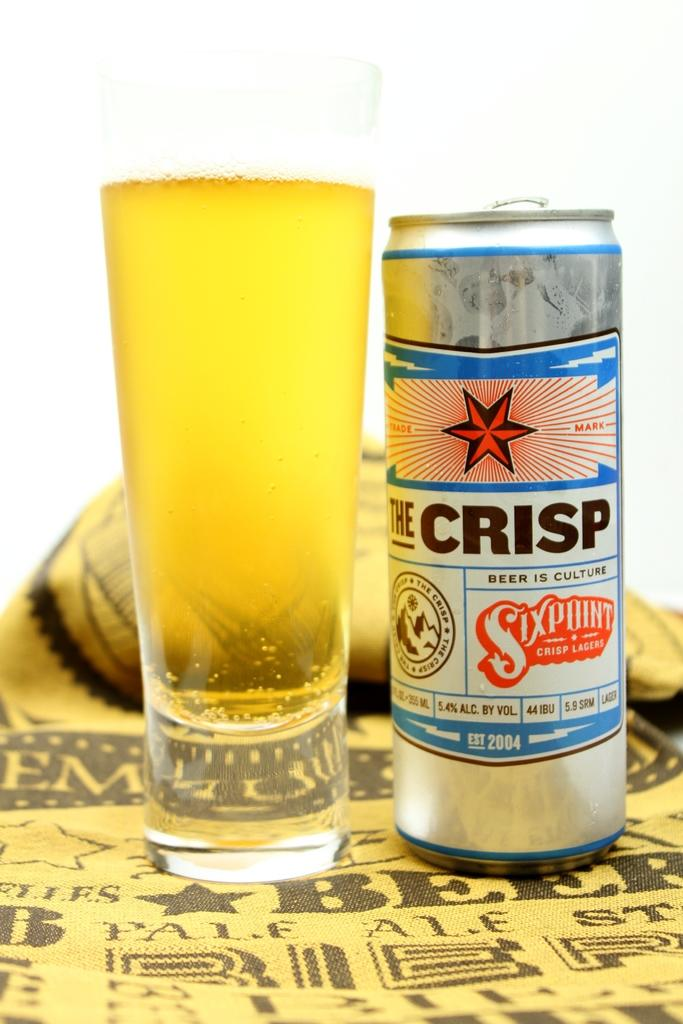What is contained in the glass that is visible in the image? There is a drink in the glass that is visible in the image. What other object can be seen in the image besides the glass? There is a tin in the image. On what surface are the glass and tin placed? Both the glass and tin are on a brown color sheet. What is the color of the background in the image? The background of the image is white. Can you see any worms crawling on the tin in the image? There are no worms present in the image; it only features a glass with a drink and a tin on a brown color sheet against a white background. 